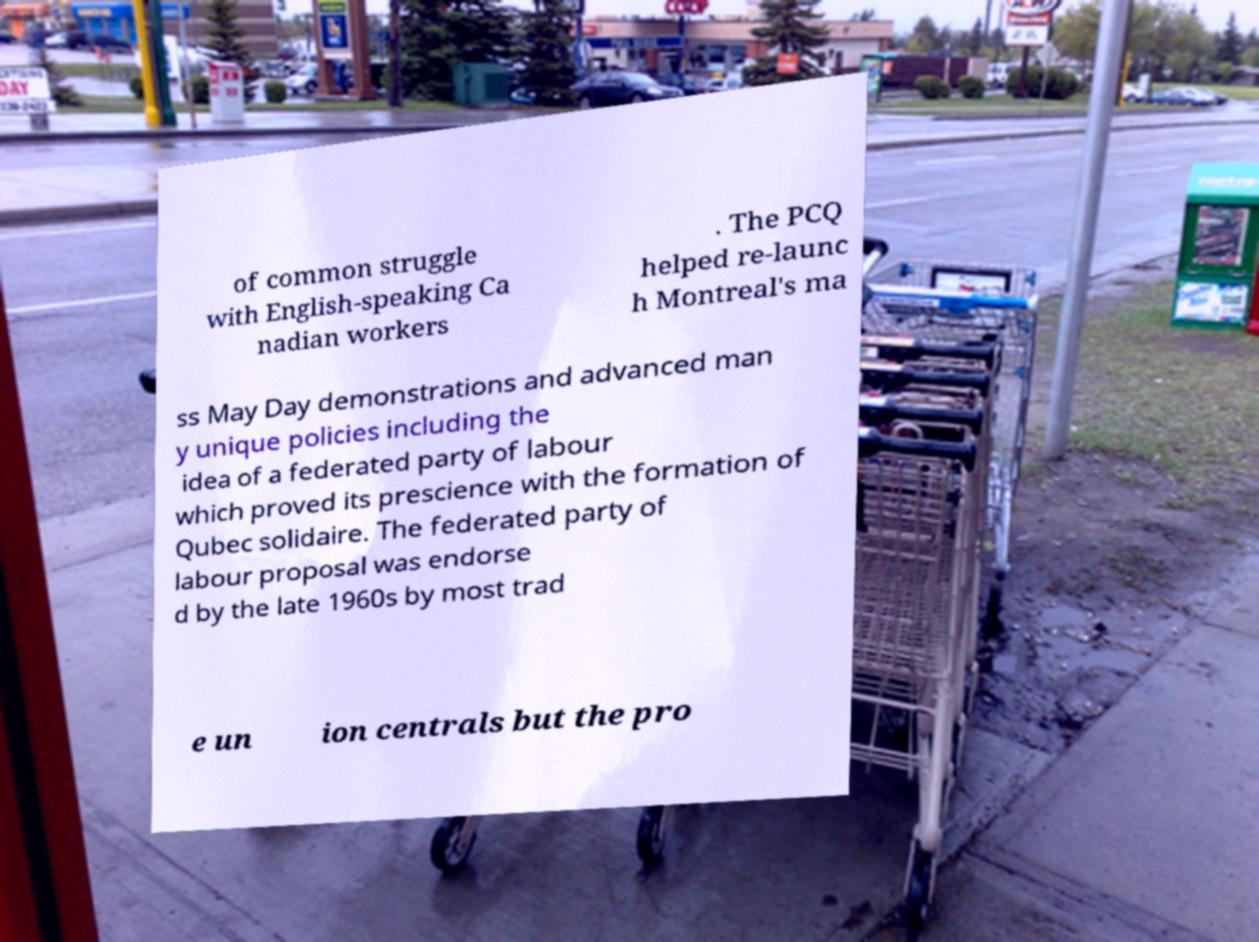I need the written content from this picture converted into text. Can you do that? of common struggle with English-speaking Ca nadian workers . The PCQ helped re-launc h Montreal's ma ss May Day demonstrations and advanced man y unique policies including the idea of a federated party of labour which proved its prescience with the formation of Qubec solidaire. The federated party of labour proposal was endorse d by the late 1960s by most trad e un ion centrals but the pro 